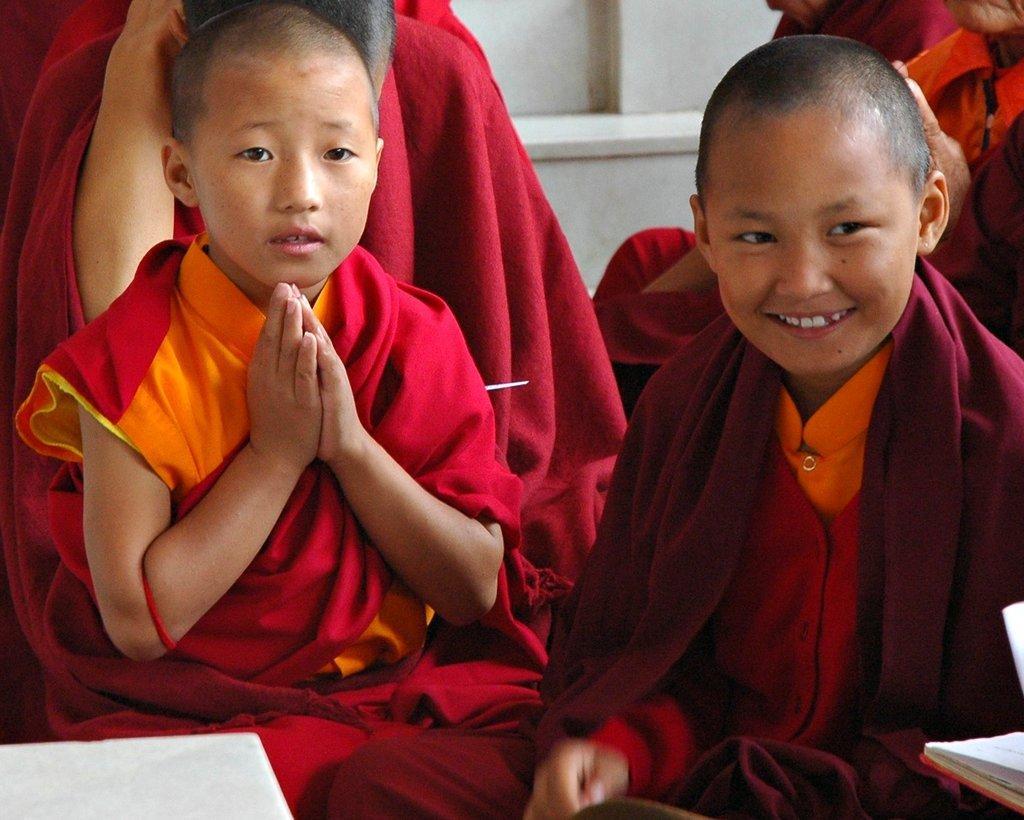In one or two sentences, can you explain what this image depicts? In the image we can see there are people sitting and there are two kids in front wearing red colour dress. One kid is smiling another kid is holding hands and at the background there is a wall made up of white marble. 